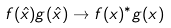Convert formula to latex. <formula><loc_0><loc_0><loc_500><loc_500>f ( \hat { x } ) g ( \hat { x } ) \rightarrow f ( x ) ^ { * } g ( x )</formula> 